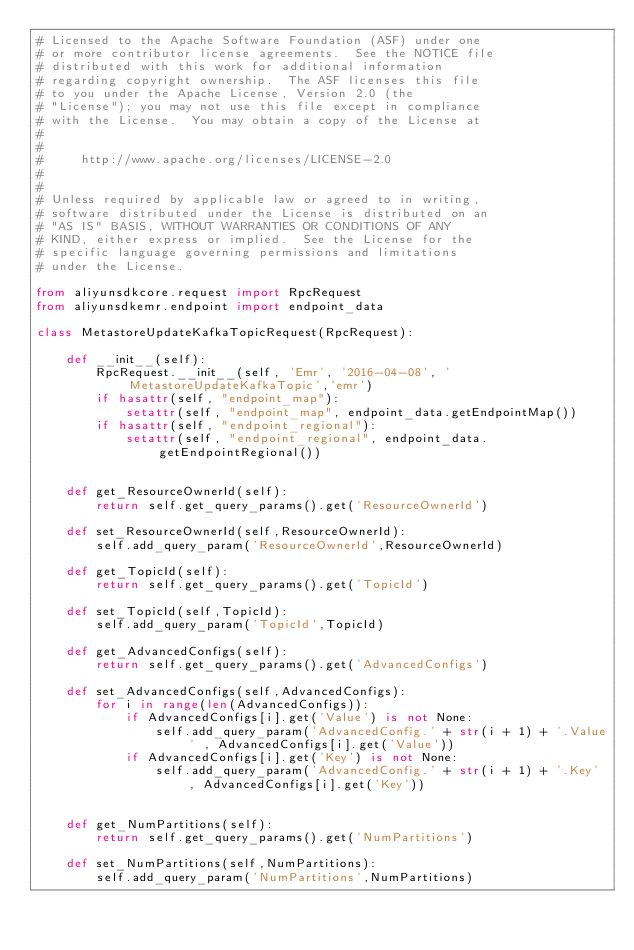Convert code to text. <code><loc_0><loc_0><loc_500><loc_500><_Python_># Licensed to the Apache Software Foundation (ASF) under one
# or more contributor license agreements.  See the NOTICE file
# distributed with this work for additional information
# regarding copyright ownership.  The ASF licenses this file
# to you under the Apache License, Version 2.0 (the
# "License"); you may not use this file except in compliance
# with the License.  You may obtain a copy of the License at
#
#
#     http://www.apache.org/licenses/LICENSE-2.0
#
#
# Unless required by applicable law or agreed to in writing,
# software distributed under the License is distributed on an
# "AS IS" BASIS, WITHOUT WARRANTIES OR CONDITIONS OF ANY
# KIND, either express or implied.  See the License for the
# specific language governing permissions and limitations
# under the License.

from aliyunsdkcore.request import RpcRequest
from aliyunsdkemr.endpoint import endpoint_data

class MetastoreUpdateKafkaTopicRequest(RpcRequest):

	def __init__(self):
		RpcRequest.__init__(self, 'Emr', '2016-04-08', 'MetastoreUpdateKafkaTopic','emr')
		if hasattr(self, "endpoint_map"):
			setattr(self, "endpoint_map", endpoint_data.getEndpointMap())
		if hasattr(self, "endpoint_regional"):
			setattr(self, "endpoint_regional", endpoint_data.getEndpointRegional())


	def get_ResourceOwnerId(self):
		return self.get_query_params().get('ResourceOwnerId')

	def set_ResourceOwnerId(self,ResourceOwnerId):
		self.add_query_param('ResourceOwnerId',ResourceOwnerId)

	def get_TopicId(self):
		return self.get_query_params().get('TopicId')

	def set_TopicId(self,TopicId):
		self.add_query_param('TopicId',TopicId)

	def get_AdvancedConfigs(self):
		return self.get_query_params().get('AdvancedConfigs')

	def set_AdvancedConfigs(self,AdvancedConfigs):
		for i in range(len(AdvancedConfigs)):	
			if AdvancedConfigs[i].get('Value') is not None:
				self.add_query_param('AdvancedConfig.' + str(i + 1) + '.Value' , AdvancedConfigs[i].get('Value'))
			if AdvancedConfigs[i].get('Key') is not None:
				self.add_query_param('AdvancedConfig.' + str(i + 1) + '.Key' , AdvancedConfigs[i].get('Key'))


	def get_NumPartitions(self):
		return self.get_query_params().get('NumPartitions')

	def set_NumPartitions(self,NumPartitions):
		self.add_query_param('NumPartitions',NumPartitions)</code> 